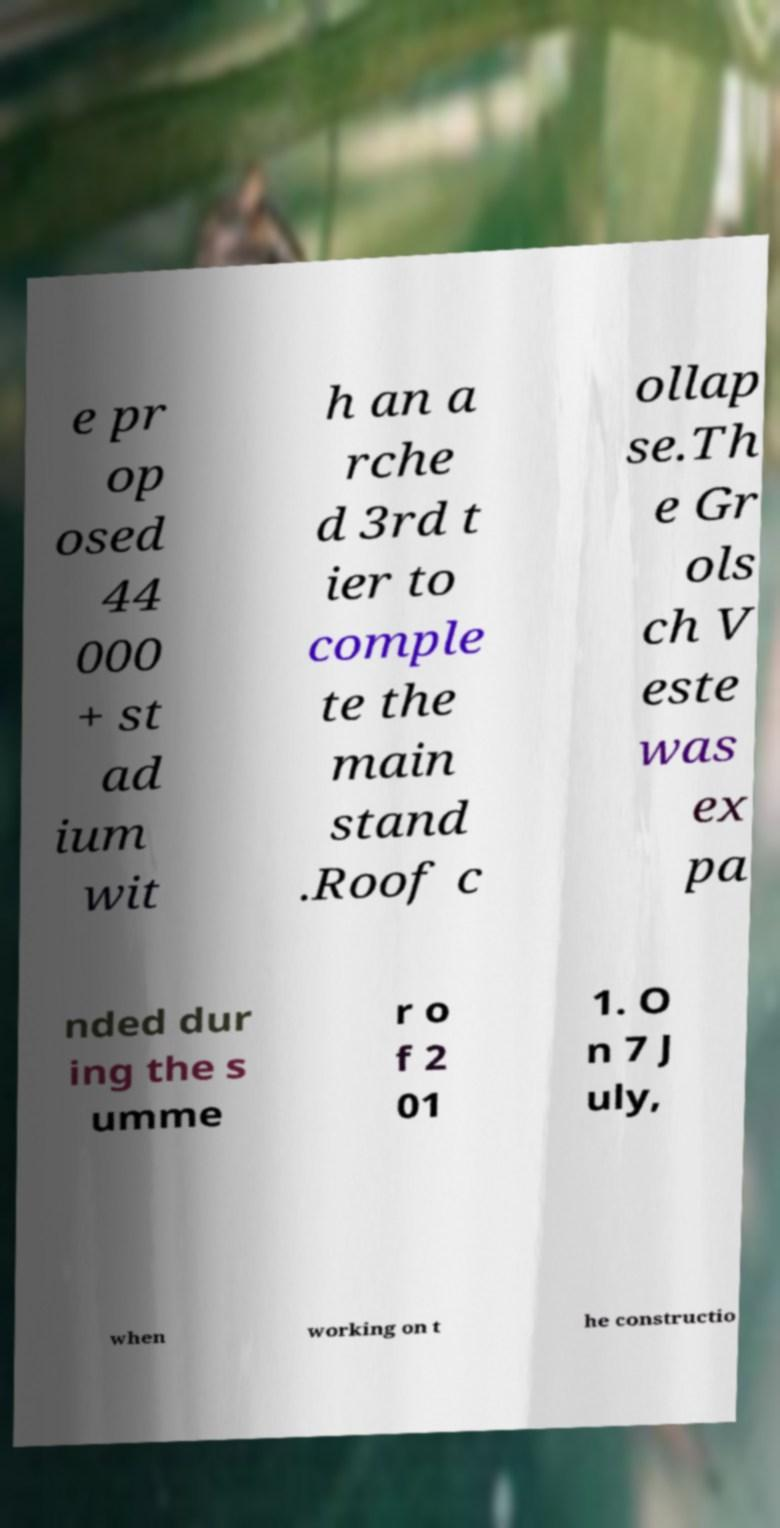Can you read and provide the text displayed in the image?This photo seems to have some interesting text. Can you extract and type it out for me? e pr op osed 44 000 + st ad ium wit h an a rche d 3rd t ier to comple te the main stand .Roof c ollap se.Th e Gr ols ch V este was ex pa nded dur ing the s umme r o f 2 01 1. O n 7 J uly, when working on t he constructio 